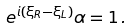<formula> <loc_0><loc_0><loc_500><loc_500>e ^ { i ( \xi _ { R } - \xi _ { L } ) } \alpha = 1 \, .</formula> 